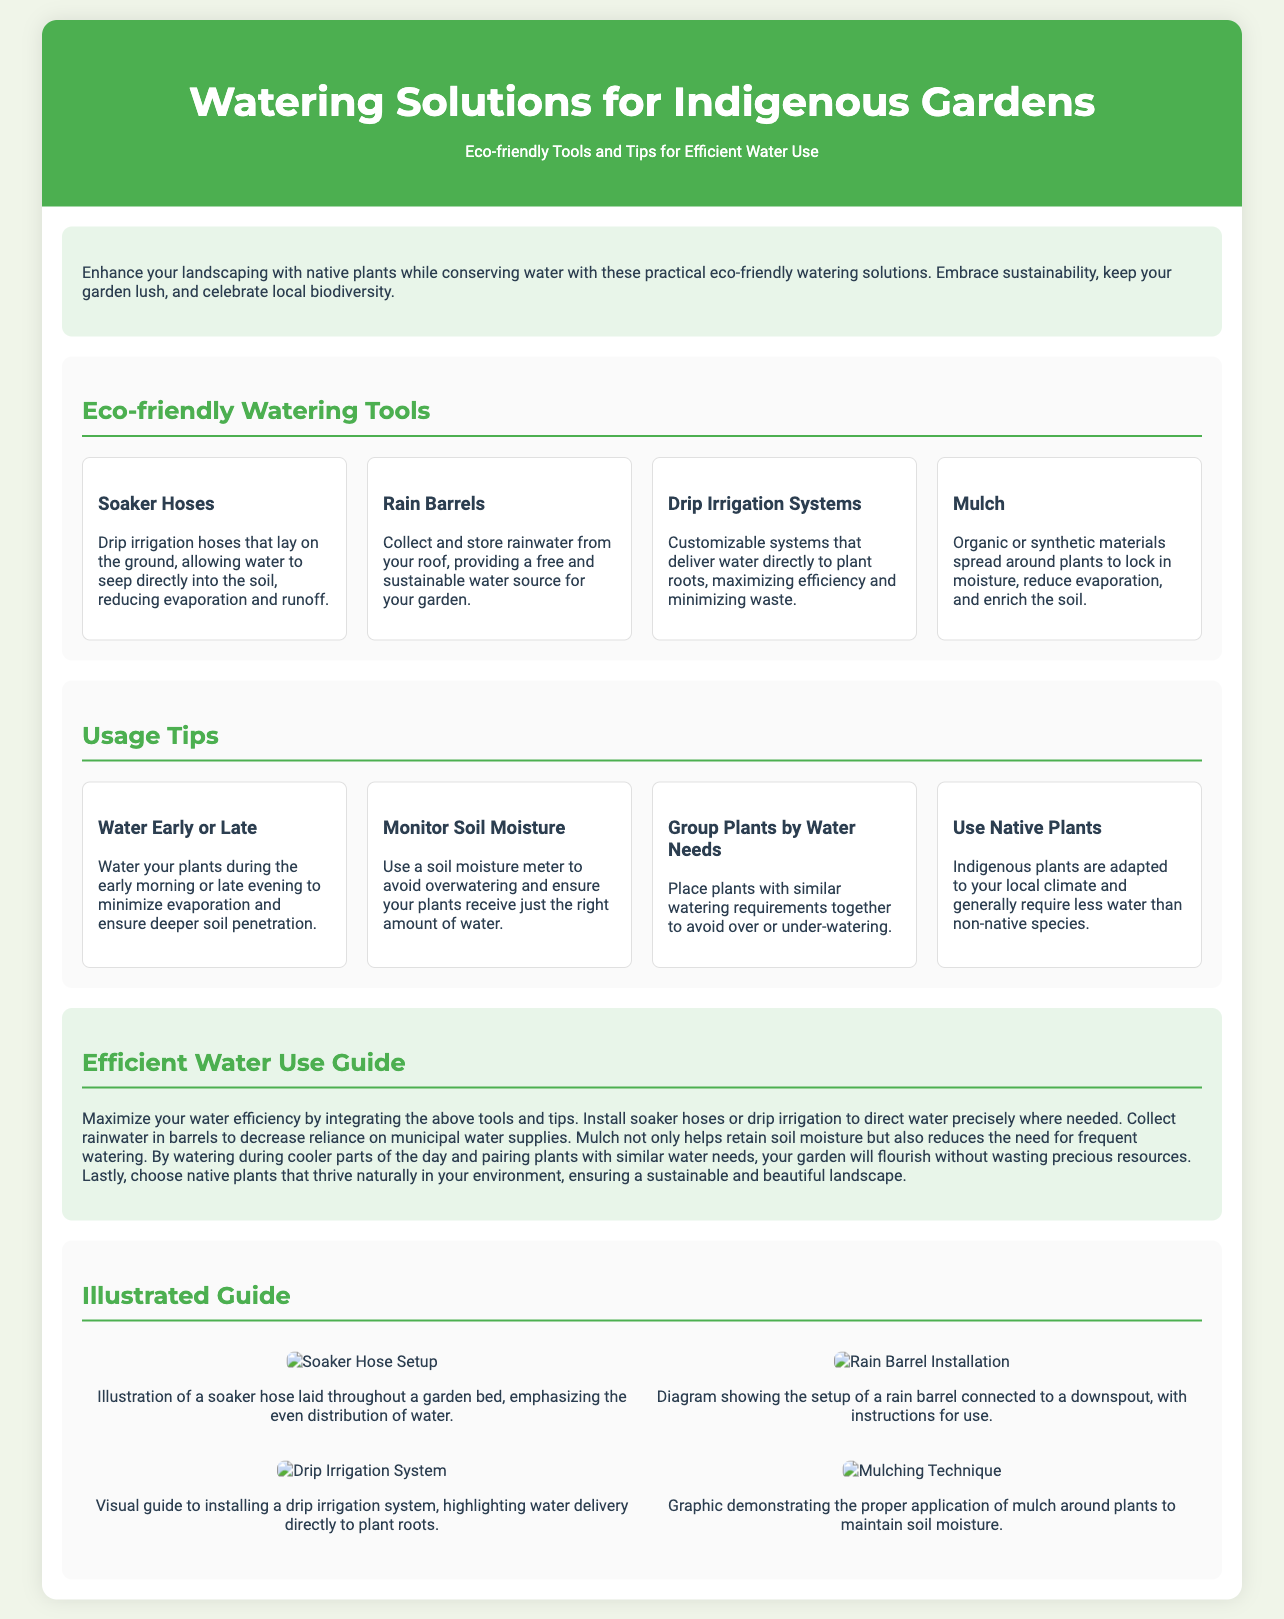what is the title of the document? The title of the document is stated in the header section and is "Watering Solutions for Indigenous Gardens."
Answer: Watering Solutions for Indigenous Gardens how many eco-friendly watering tools are listed? The number of tools is found in the section "Eco-friendly Watering Tools," which lists four tools.
Answer: Four what should you do to minimize evaporation while watering? This is stated in the "Usage Tips" section, which suggests watering in the early morning or late evening.
Answer: Water early or late what type of irrigation is mentioned that delivers water directly to plant roots? The document references a specific irrigation system in the "Eco-friendly Watering Tools" section, which is called "Drip Irrigation Systems."
Answer: Drip Irrigation Systems what plant type is recommended for reduced water needs? The "Usage Tips" section suggests using plants that are adapted to local conditions.
Answer: Native plants how does mulching affect watering frequency? The "Guide" states that mulching helps retain soil moisture, which reduces the need for frequent watering.
Answer: Reduces the need for frequent watering what is suggested to monitor watering levels? The document recommends using a specific device in the "Usage Tips" section to avoid overwatering.
Answer: Soil moisture meter which watering tool collects rainwater? The section on watering tools highlights a specific tool that allows for rainwater collection.
Answer: Rain Barrels 